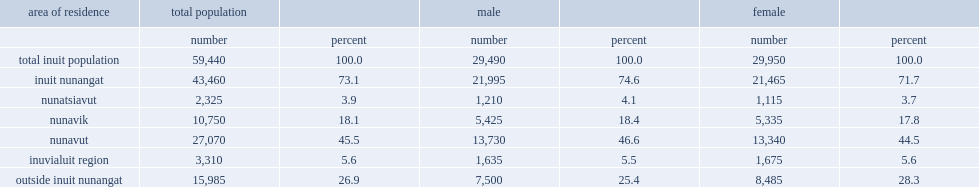In 2011, how many inuit lived in canada? 59440.0. How many percentages of inuit lived in inuit nunangat? 73.1. How many inuit lived outside inuit nunangat? 15985.0. What was a total number of inuit women and girls in canada in 2011? 29950.0. What was a total number of inuit women and girls in canada in 2011? 21465.0. What was a total number of inuit women and girls in canada in 2011? 8485.0. What was the number of inuit nunavut females in the region? 13340.0. What was the number of inuit females in the region nunavik? 5335.0. 